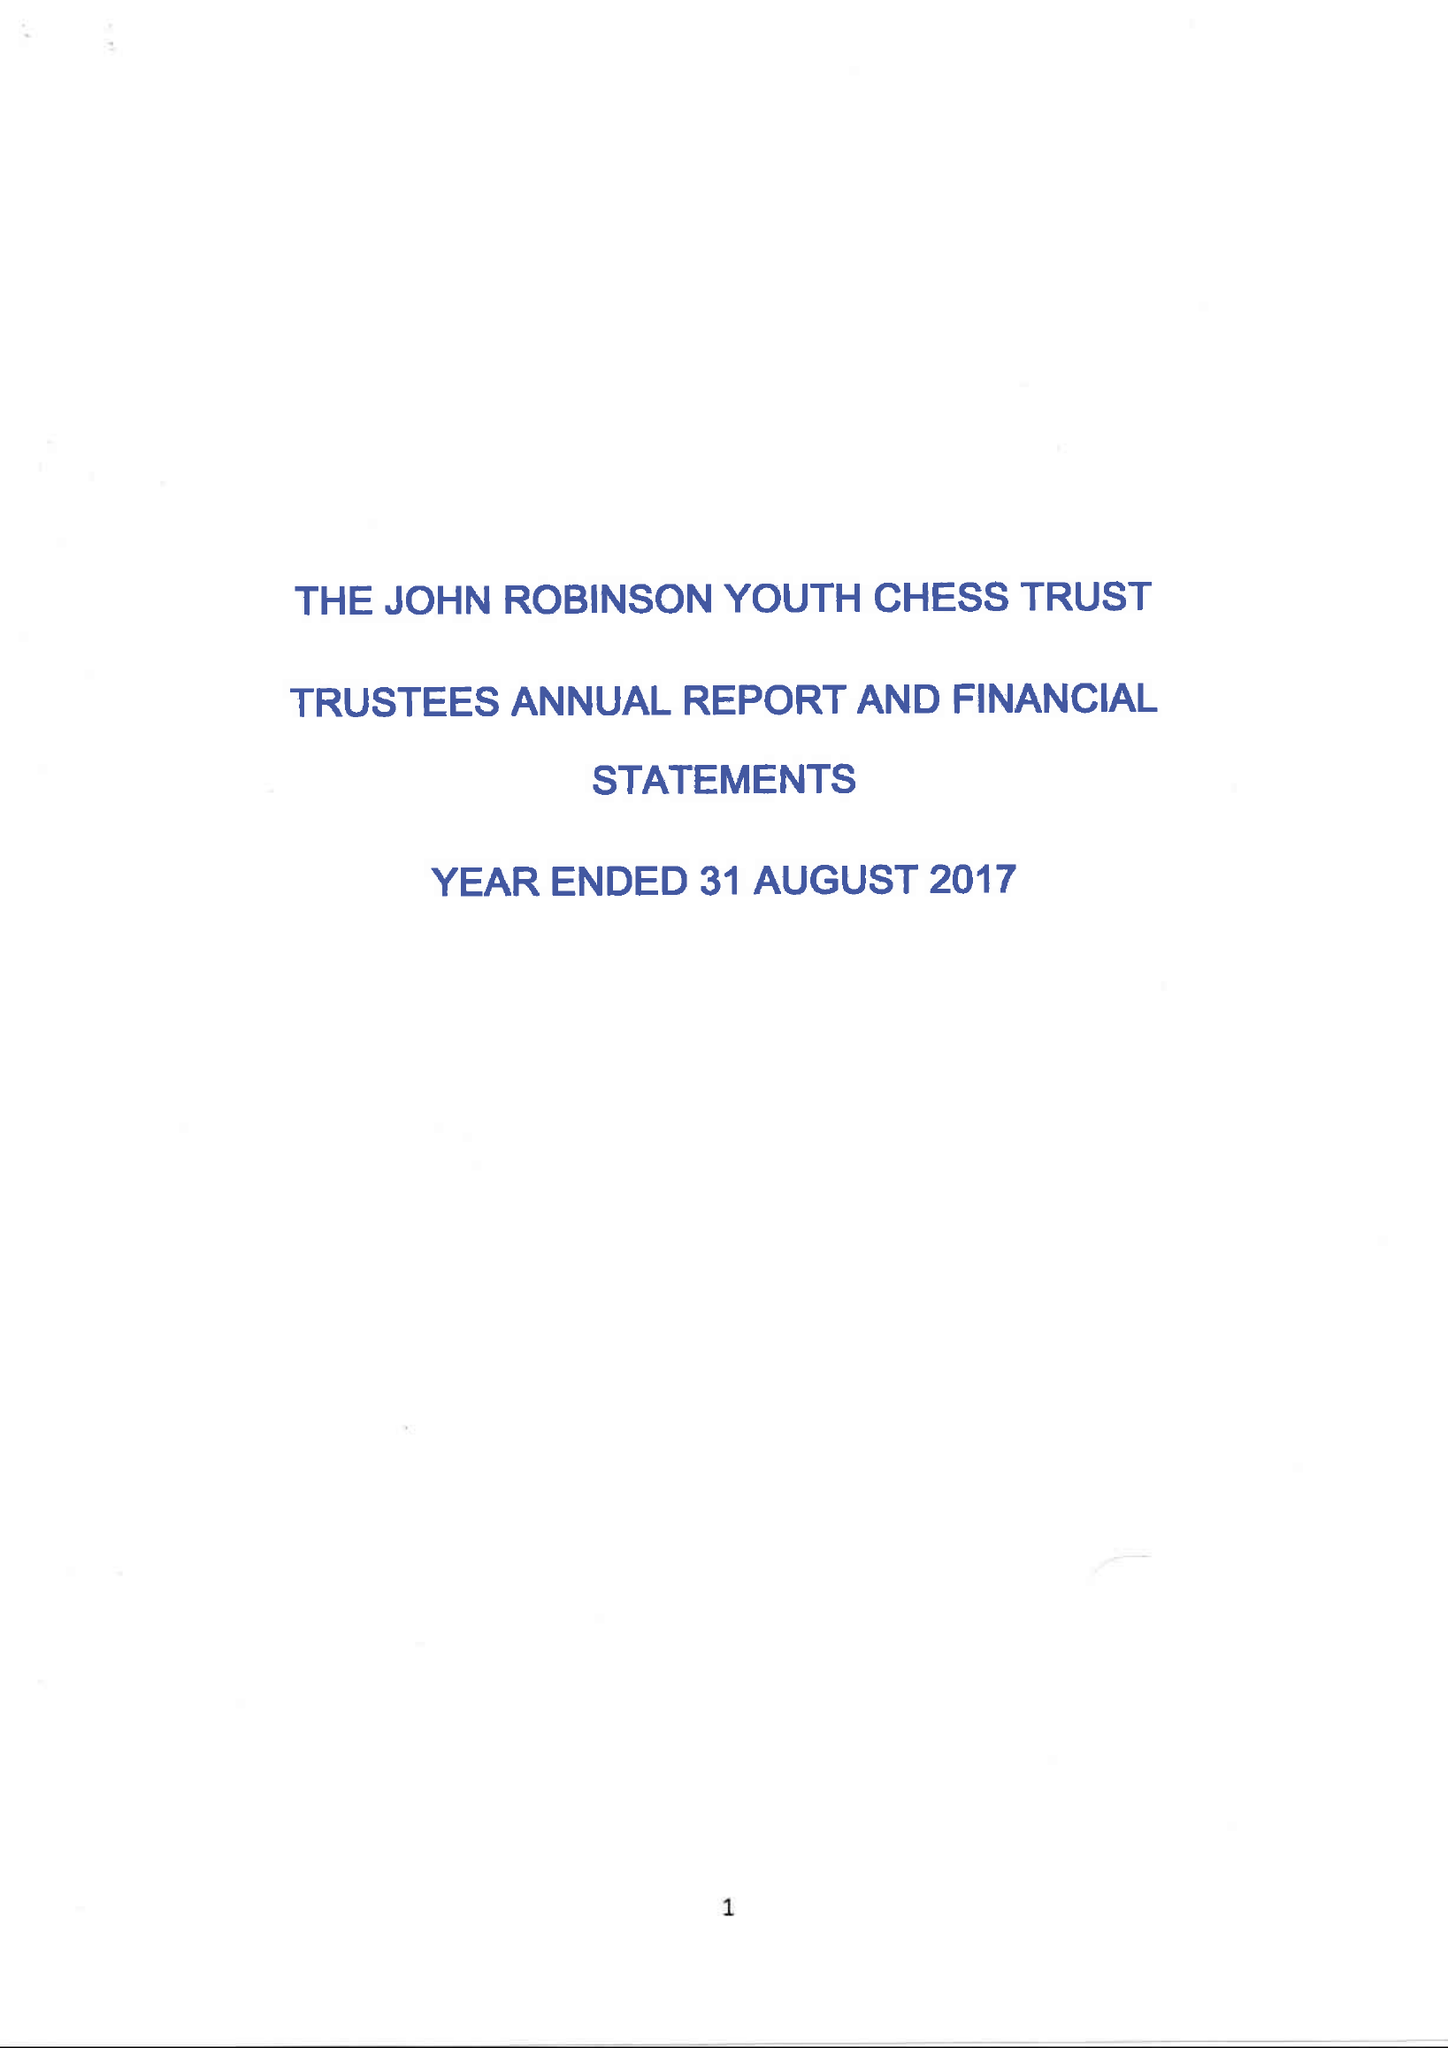What is the value for the address__post_town?
Answer the question using a single word or phrase. CRAWLEY 